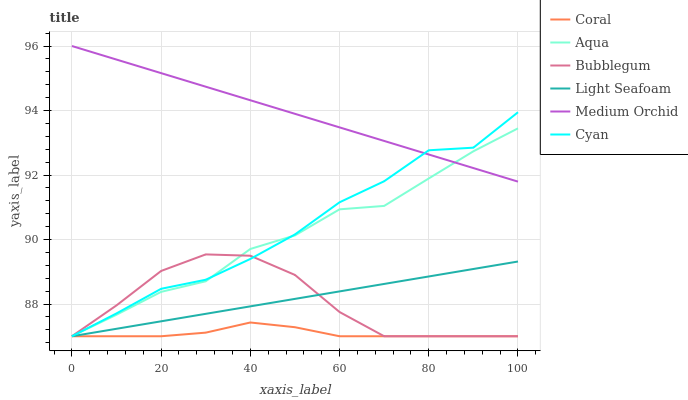Does Coral have the minimum area under the curve?
Answer yes or no. Yes. Does Medium Orchid have the maximum area under the curve?
Answer yes or no. Yes. Does Aqua have the minimum area under the curve?
Answer yes or no. No. Does Aqua have the maximum area under the curve?
Answer yes or no. No. Is Light Seafoam the smoothest?
Answer yes or no. Yes. Is Cyan the roughest?
Answer yes or no. Yes. Is Medium Orchid the smoothest?
Answer yes or no. No. Is Medium Orchid the roughest?
Answer yes or no. No. Does Coral have the lowest value?
Answer yes or no. Yes. Does Aqua have the lowest value?
Answer yes or no. No. Does Medium Orchid have the highest value?
Answer yes or no. Yes. Does Aqua have the highest value?
Answer yes or no. No. Is Coral less than Aqua?
Answer yes or no. Yes. Is Medium Orchid greater than Light Seafoam?
Answer yes or no. Yes. Does Coral intersect Bubblegum?
Answer yes or no. Yes. Is Coral less than Bubblegum?
Answer yes or no. No. Is Coral greater than Bubblegum?
Answer yes or no. No. Does Coral intersect Aqua?
Answer yes or no. No. 